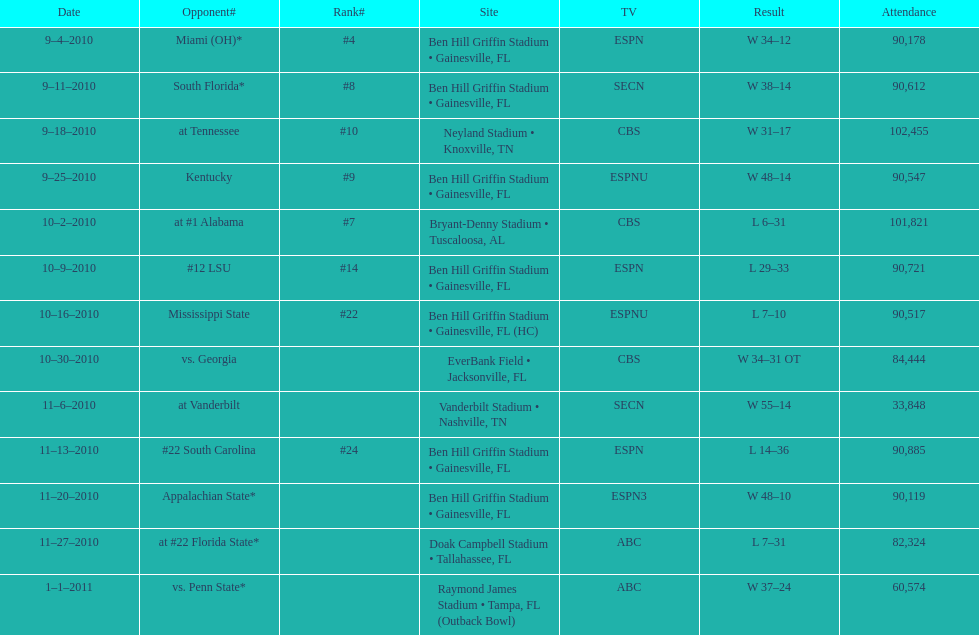How many games did the university of florida win by at least 10 points? 7. 